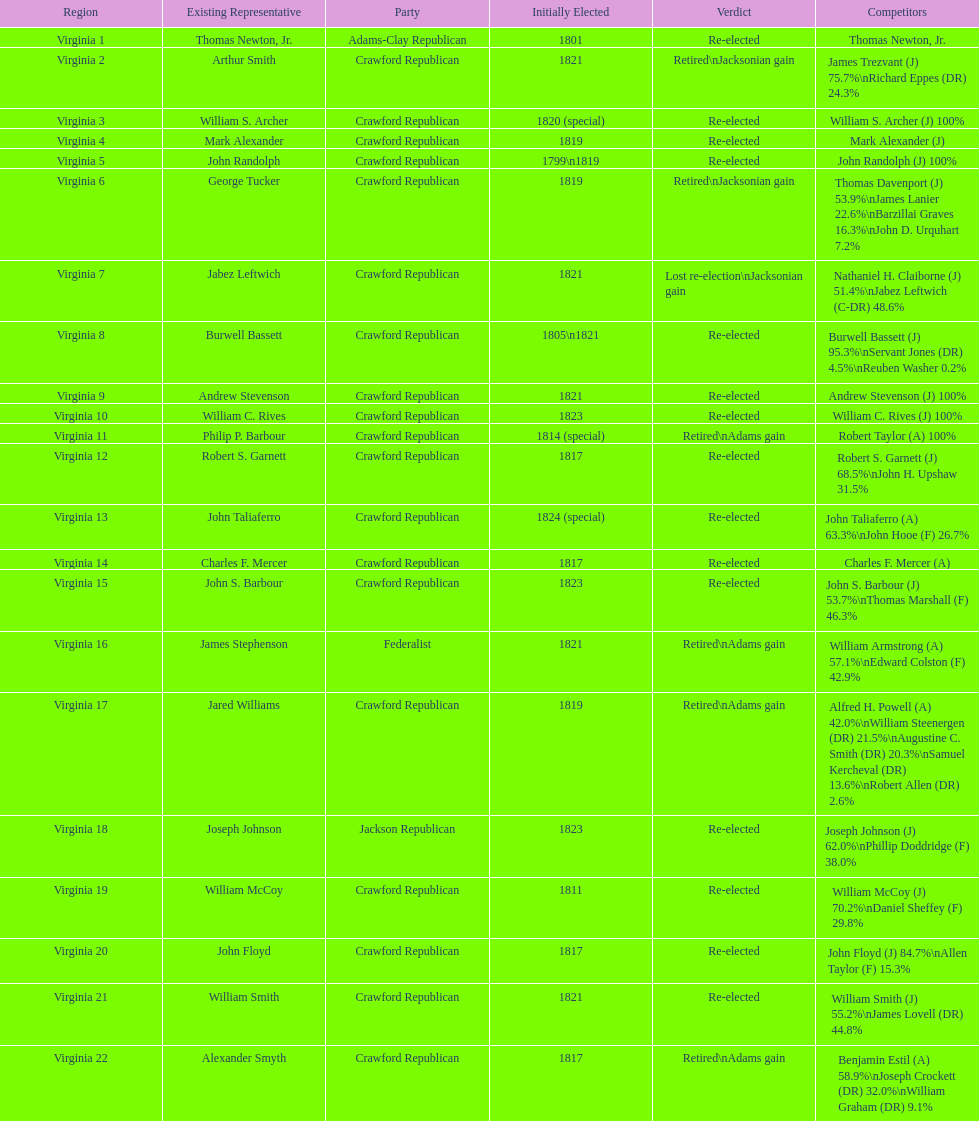Name the only candidate that was first elected in 1811. William McCoy. 